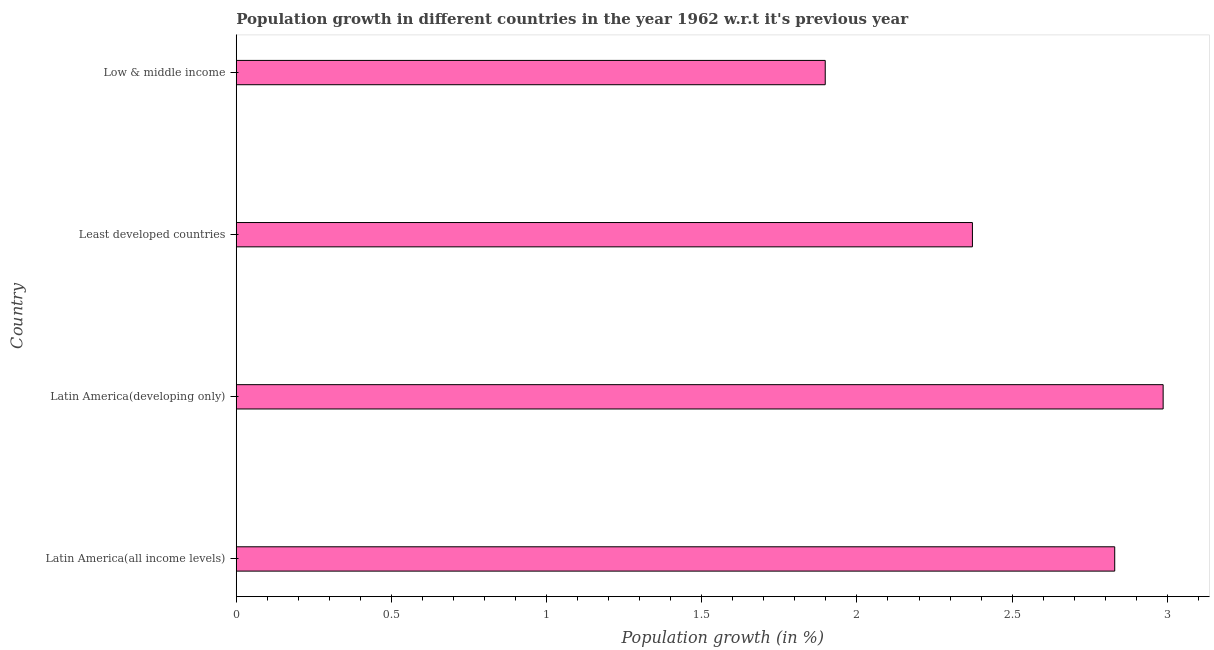Does the graph contain grids?
Ensure brevity in your answer.  No. What is the title of the graph?
Provide a short and direct response. Population growth in different countries in the year 1962 w.r.t it's previous year. What is the label or title of the X-axis?
Ensure brevity in your answer.  Population growth (in %). What is the population growth in Latin America(developing only)?
Your answer should be compact. 2.99. Across all countries, what is the maximum population growth?
Your answer should be very brief. 2.99. Across all countries, what is the minimum population growth?
Make the answer very short. 1.9. In which country was the population growth maximum?
Make the answer very short. Latin America(developing only). What is the sum of the population growth?
Provide a succinct answer. 10.09. What is the difference between the population growth in Latin America(developing only) and Least developed countries?
Offer a terse response. 0.61. What is the average population growth per country?
Make the answer very short. 2.52. What is the median population growth?
Provide a short and direct response. 2.6. In how many countries, is the population growth greater than 0.8 %?
Provide a short and direct response. 4. What is the ratio of the population growth in Least developed countries to that in Low & middle income?
Offer a very short reply. 1.25. Is the population growth in Latin America(all income levels) less than that in Latin America(developing only)?
Provide a short and direct response. Yes. Is the difference between the population growth in Least developed countries and Low & middle income greater than the difference between any two countries?
Provide a short and direct response. No. What is the difference between the highest and the second highest population growth?
Your response must be concise. 0.16. What is the difference between the highest and the lowest population growth?
Ensure brevity in your answer.  1.09. How many countries are there in the graph?
Your answer should be compact. 4. What is the difference between two consecutive major ticks on the X-axis?
Make the answer very short. 0.5. What is the Population growth (in %) in Latin America(all income levels)?
Make the answer very short. 2.83. What is the Population growth (in %) in Latin America(developing only)?
Offer a very short reply. 2.99. What is the Population growth (in %) in Least developed countries?
Your response must be concise. 2.37. What is the Population growth (in %) of Low & middle income?
Your answer should be compact. 1.9. What is the difference between the Population growth (in %) in Latin America(all income levels) and Latin America(developing only)?
Offer a terse response. -0.16. What is the difference between the Population growth (in %) in Latin America(all income levels) and Least developed countries?
Your answer should be very brief. 0.46. What is the difference between the Population growth (in %) in Latin America(all income levels) and Low & middle income?
Provide a short and direct response. 0.93. What is the difference between the Population growth (in %) in Latin America(developing only) and Least developed countries?
Your answer should be very brief. 0.61. What is the difference between the Population growth (in %) in Latin America(developing only) and Low & middle income?
Your answer should be very brief. 1.09. What is the difference between the Population growth (in %) in Least developed countries and Low & middle income?
Keep it short and to the point. 0.47. What is the ratio of the Population growth (in %) in Latin America(all income levels) to that in Latin America(developing only)?
Ensure brevity in your answer.  0.95. What is the ratio of the Population growth (in %) in Latin America(all income levels) to that in Least developed countries?
Ensure brevity in your answer.  1.19. What is the ratio of the Population growth (in %) in Latin America(all income levels) to that in Low & middle income?
Your answer should be compact. 1.49. What is the ratio of the Population growth (in %) in Latin America(developing only) to that in Least developed countries?
Your answer should be compact. 1.26. What is the ratio of the Population growth (in %) in Latin America(developing only) to that in Low & middle income?
Ensure brevity in your answer.  1.57. 